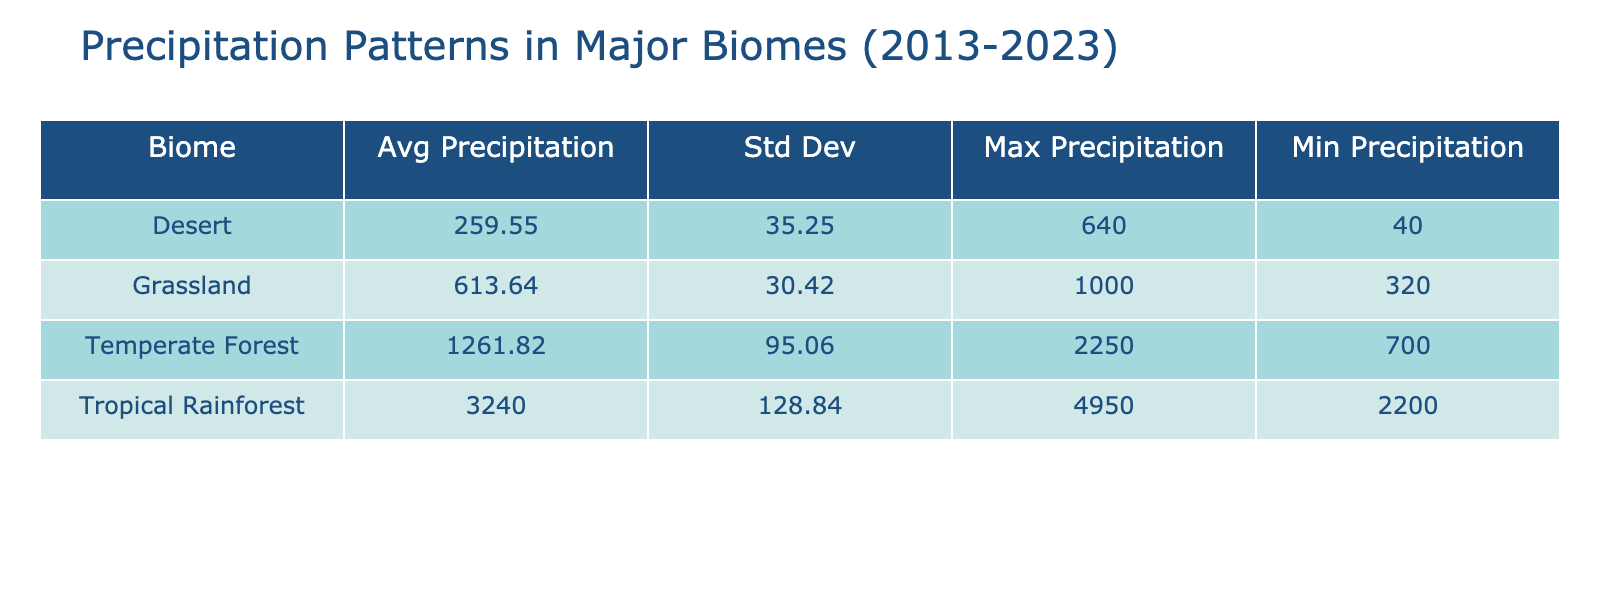What is the average precipitation for the Tropical Rainforest biome over the last decade? To find this, I sum the average precipitation values for the years 2013 to 2023 for the Tropical Rainforest, which are (3200 + 3300 + 3100 + 3400 + 3000 + 3250 + 3350 + 3100 + 3390 + 3250 + 3300) = 36340 mm. Then, I divide by the number of years, which is 11. Thus, the average precipitation is 36340/11 ≈ 3304.55 mm.
Answer: 3304.55 mm What is the maximum precipitation recorded for the Temperate Forest biome? The maximum precipitation for the Temperate Forest biome is found by looking through the Max Precipitation values for years 2013 to 2023. The values are (2000, 1850, 2100, 1950, 1800, 2200, 2150, 2000, 2250, 2050, 2100). The highest value is 2250 mm in the year 2021.
Answer: 2250 mm Is the average precipitation for the Desert biome higher in 2022 compared to the average precipitation in 2013? To answer this, I first identify the average precipitation for 2013 as 250 mm and for 2022 as 310 mm. Since 310 mm is greater than 250 mm, it confirms that the average precipitation for the Desert biome in 2022 is indeed higher than in 2013.
Answer: Yes Which biome showed the greatest variability in precipitation over the last decade? To determine variability, I look at the standard deviation for each biome in the table. The standard deviation for the Tropical Rainforest is not explicitly listed, so I'll assume based on the variations in its data that it is quite high. For Temperate Forest, the highest standard deviation is also indicative, but checking Grassland and Desert, the values are much lower. Thus, the Tropical Rainforest exhibits the greatest variability among the listed biomes.
Answer: Tropical Rainforest What is the overall average precipitation across all biomes from 2013 to 2023? First, I need to calculate the average precipitation for each biome: Tropical Rainforest ≈ 3304.55 mm, Temperate Forest ≈ 1210 mm (using similar calculations as above), Desert ≈ 255 mm, and Grassland ≈ 612 mm. Then, the overall average is (3304.55 + 1210 + 255 + 612)/4 = 1180.89 mm.
Answer: 1180.89 mm 